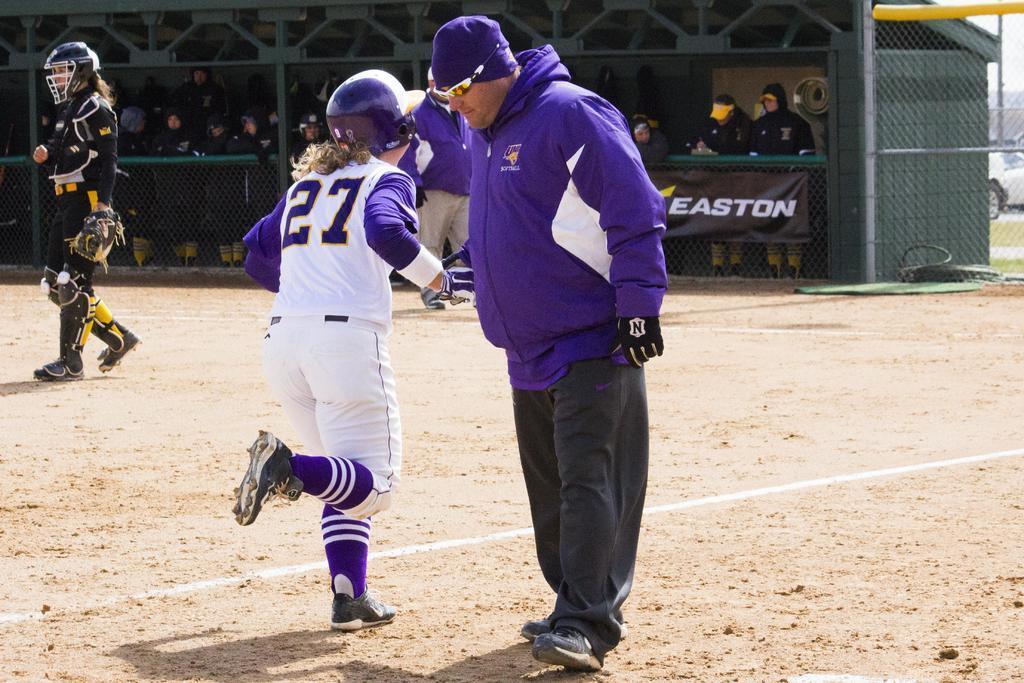Could you give a brief overview of what you see in this image? Here in this picture in the front we can see a person and a woman standing on the ground over there and the woman is wearing gloves and helmet on her and beside them also we can see another woman standing with knee pads, gloves and helmet on her and behind them we can see number of people sitting and standing in the stands over there and we can see a fencing present over there and we can also see a banner present over there. 